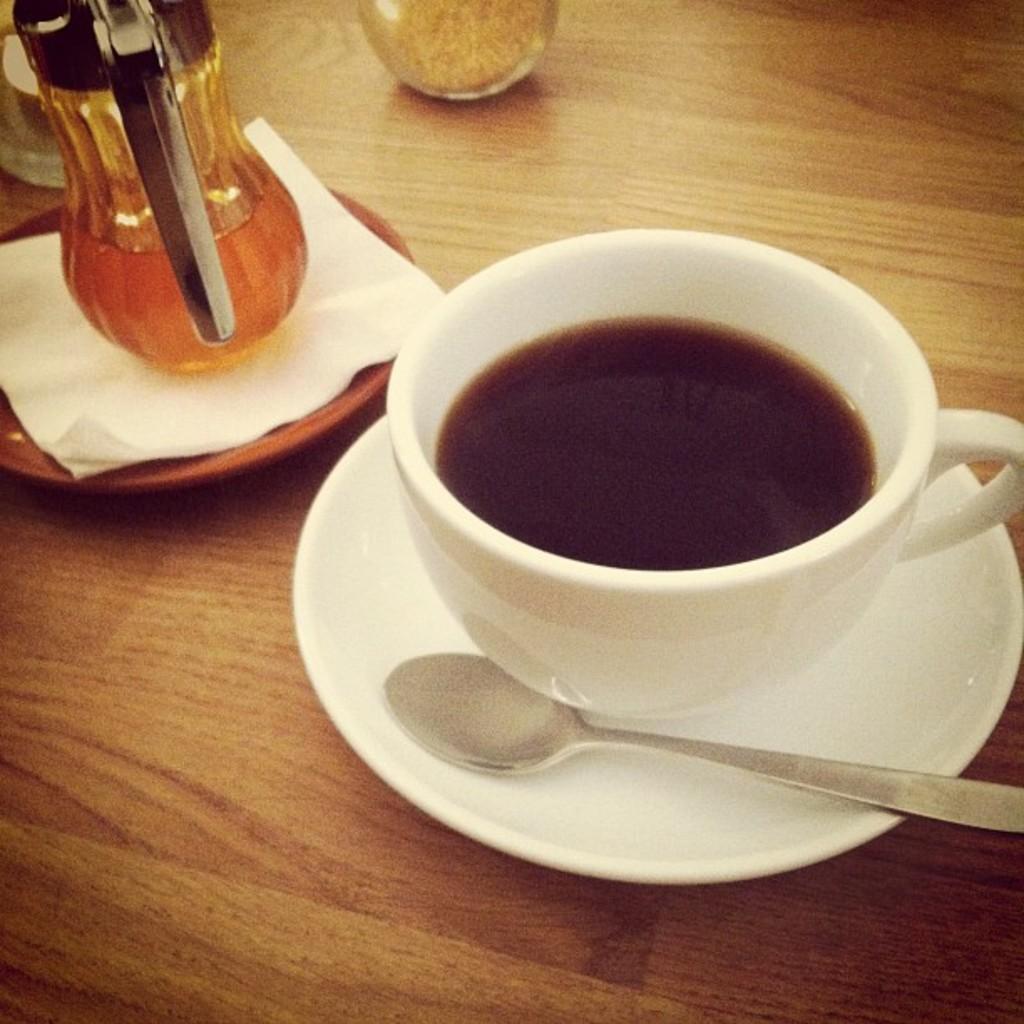How would you summarize this image in a sentence or two? Here in this picture we can see a table on which we can see a cup of coffee on a saucer with a spoon present on it over there and beside that we can see a jar of honey placed on a plate over there and e can also see other glasses also present over there. 